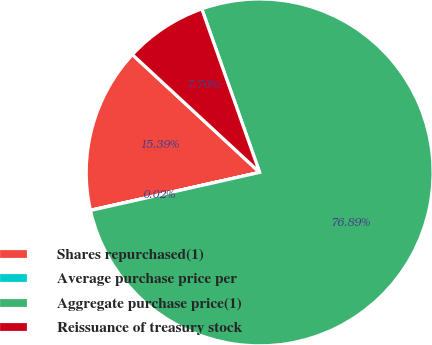Convert chart to OTSL. <chart><loc_0><loc_0><loc_500><loc_500><pie_chart><fcel>Shares repurchased(1)<fcel>Average purchase price per<fcel>Aggregate purchase price(1)<fcel>Reissuance of treasury stock<nl><fcel>15.39%<fcel>0.02%<fcel>76.89%<fcel>7.7%<nl></chart> 